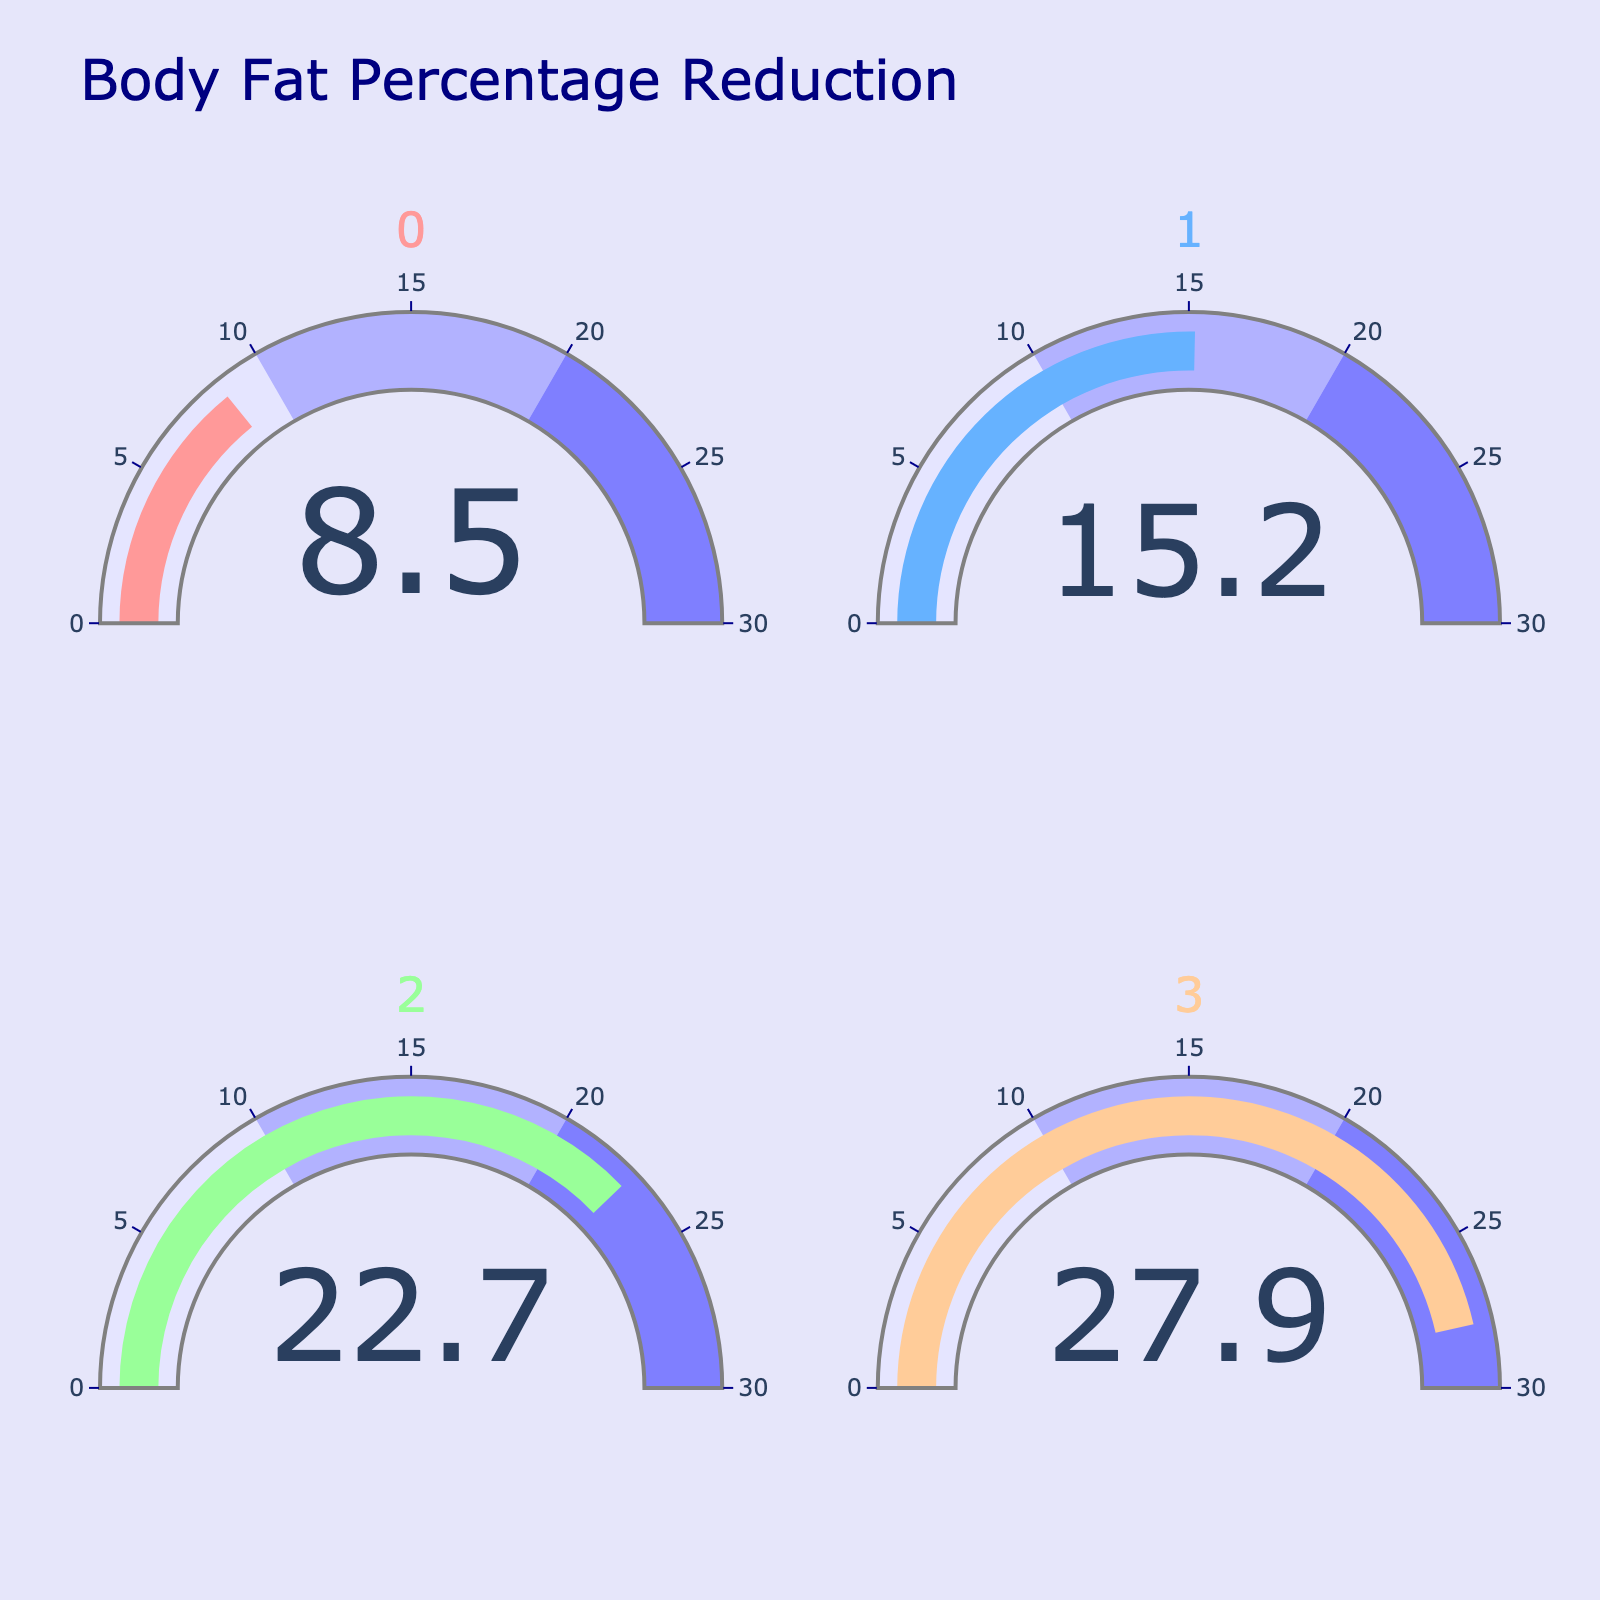what is the title of the figure? The title is usually placed at the top of the figure. In this case, the title reads "Body Fat Percentage Reduction" which is clearly stated in the figure.
Answer: Body Fat Percentage Reduction what is the body fat percentage reduction at 3 months? The gauge chart showing the body fat percentage at 3 months displays the number 8.5, which indicates an 8.5% reduction in body fat.
Answer: 8.5% what color represents the current body fat percentage reduction sector on the gauge? The current body fat percentage reduction gauge is colored differently from the others, which in this chart is represented by a distinct color assigned to the "Current" label. It is displayed in light brown (#FFCC99).
Answer: Light brown (#FFCC99) what is the difference in body fat percentage reduction between 6 months and 1 year? According to the gauge chart, the body fat percentage reduction at 6 months is 15.2%, and at 1 year, it is 22.7%. The difference calculation is 22.7% - 15.2% = 7.5%.
Answer: 7.5% how many time points are shown in the figure? There are four separate gauge charts visible in the figure, each corresponding to different time points: 3 Months, 6 Months, 1 Year, and Current.
Answer: Four (4) which time point shows the highest body fat percentage reduction? By observing the gauges, the "Current" time point shows the highest body fat percentage reduction with a value of 27.9%, which is higher than the others.
Answer: Current what is the average body fat percentage reduction over all the time points shown? To determine the average, sum up the reductions: 8.5% + 15.2% + 22.7% + 27.9% = 74.3%. Then divide by the number of time points, which is 4. So, 74.3% / 4 = 18.575%.
Answer: 18.575% how does the body fat percentage reduction at 3 months compare to the 6 months? The gauge shows that the reduction at 3 months is 8.5%, and at 6 months, it is 15.2%. The 6 months reduction is greater than the 3 months reduction.
Answer: Greater at 6 months is there any time point where the body fat percentage reduction is below 10%? By evaluating each gauge, the "3 Months" time point shows a body fat percentage reduction of 8.5%, which is below 10%.
Answer: Yes, at 3 Months how much has the body fat percentage reduction increased from 3 months to current? The gauge chart shows a reduction of 8.5% at 3 months and 27.9% currently. The increase is calculated by subtracting the 3 months value from the current value: 27.9% - 8.5% = 19.4%.
Answer: 19.4% 